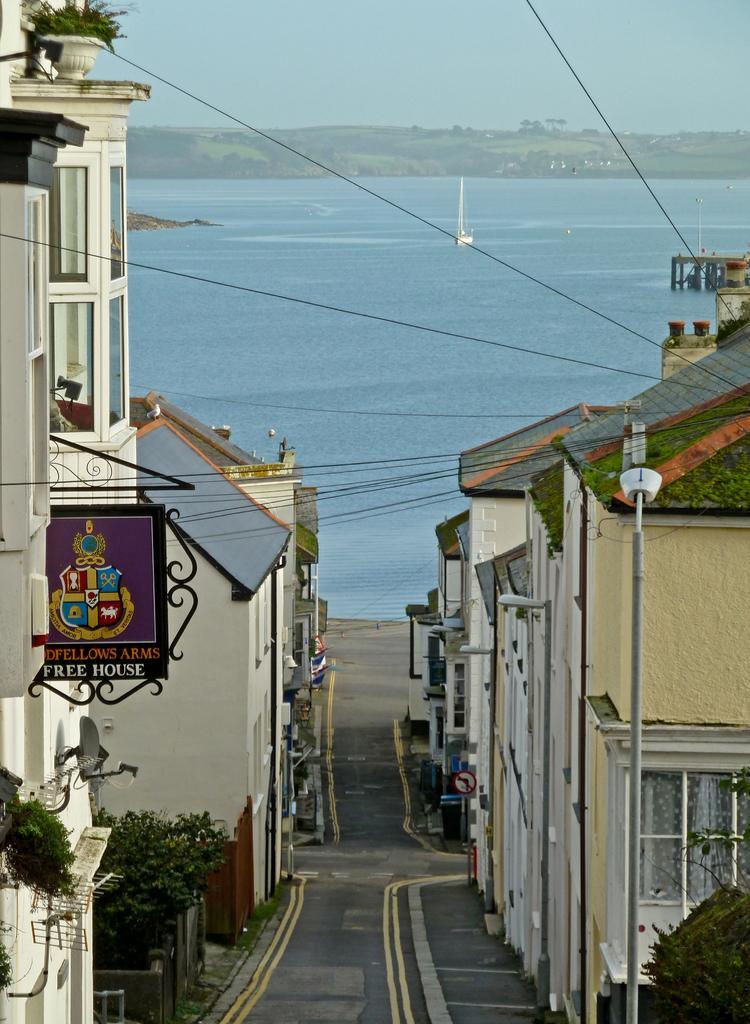Describe this image in one or two sentences. In this picture we can see some text and a few things on the boards. There are plants, poles, wires, buildings and other objects. We can see the water, a walkway and some greenery in the background. There is the sky on top. 